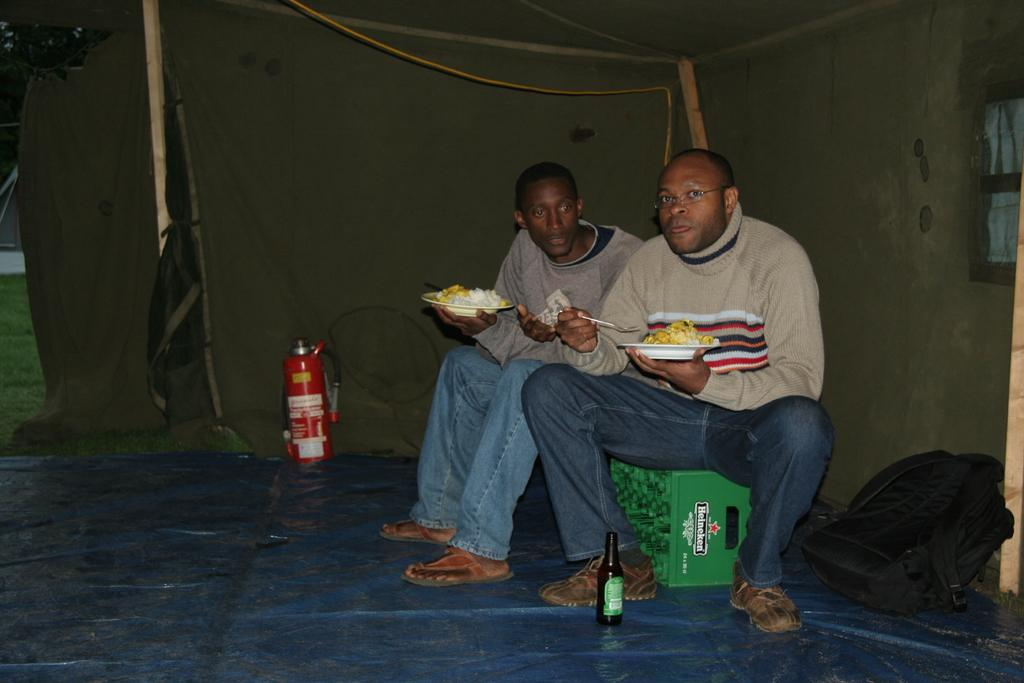How many people are in the image? There are two persons in the image. What are the persons doing in the image? The persons are sitting on a platform and holding food items. What else can be seen in the image besides the persons? There is a bottle and a fire extinguisher visible in the image. What type of knife is being used to fold the structure in the image? There is no knife or structure present in the image. 